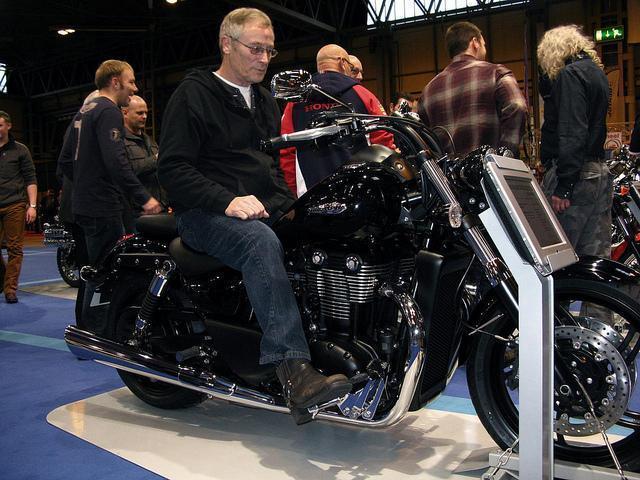How many people can be seen?
Give a very brief answer. 7. 